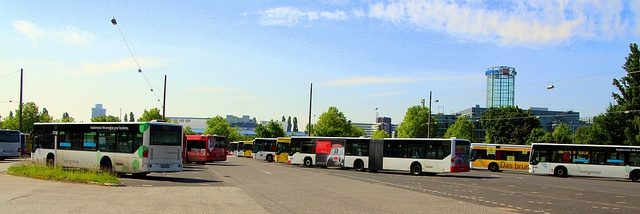Describe the objects in this image and their specific colors. I can see bus in lightblue, black, gray, darkgray, and tan tones, bus in lightblue, black, darkgray, lightgray, and gray tones, bus in lightblue, black, darkgray, gray, and ivory tones, bus in lightblue, black, darkgray, gray, and red tones, and bus in lightblue, black, olive, and orange tones in this image. 